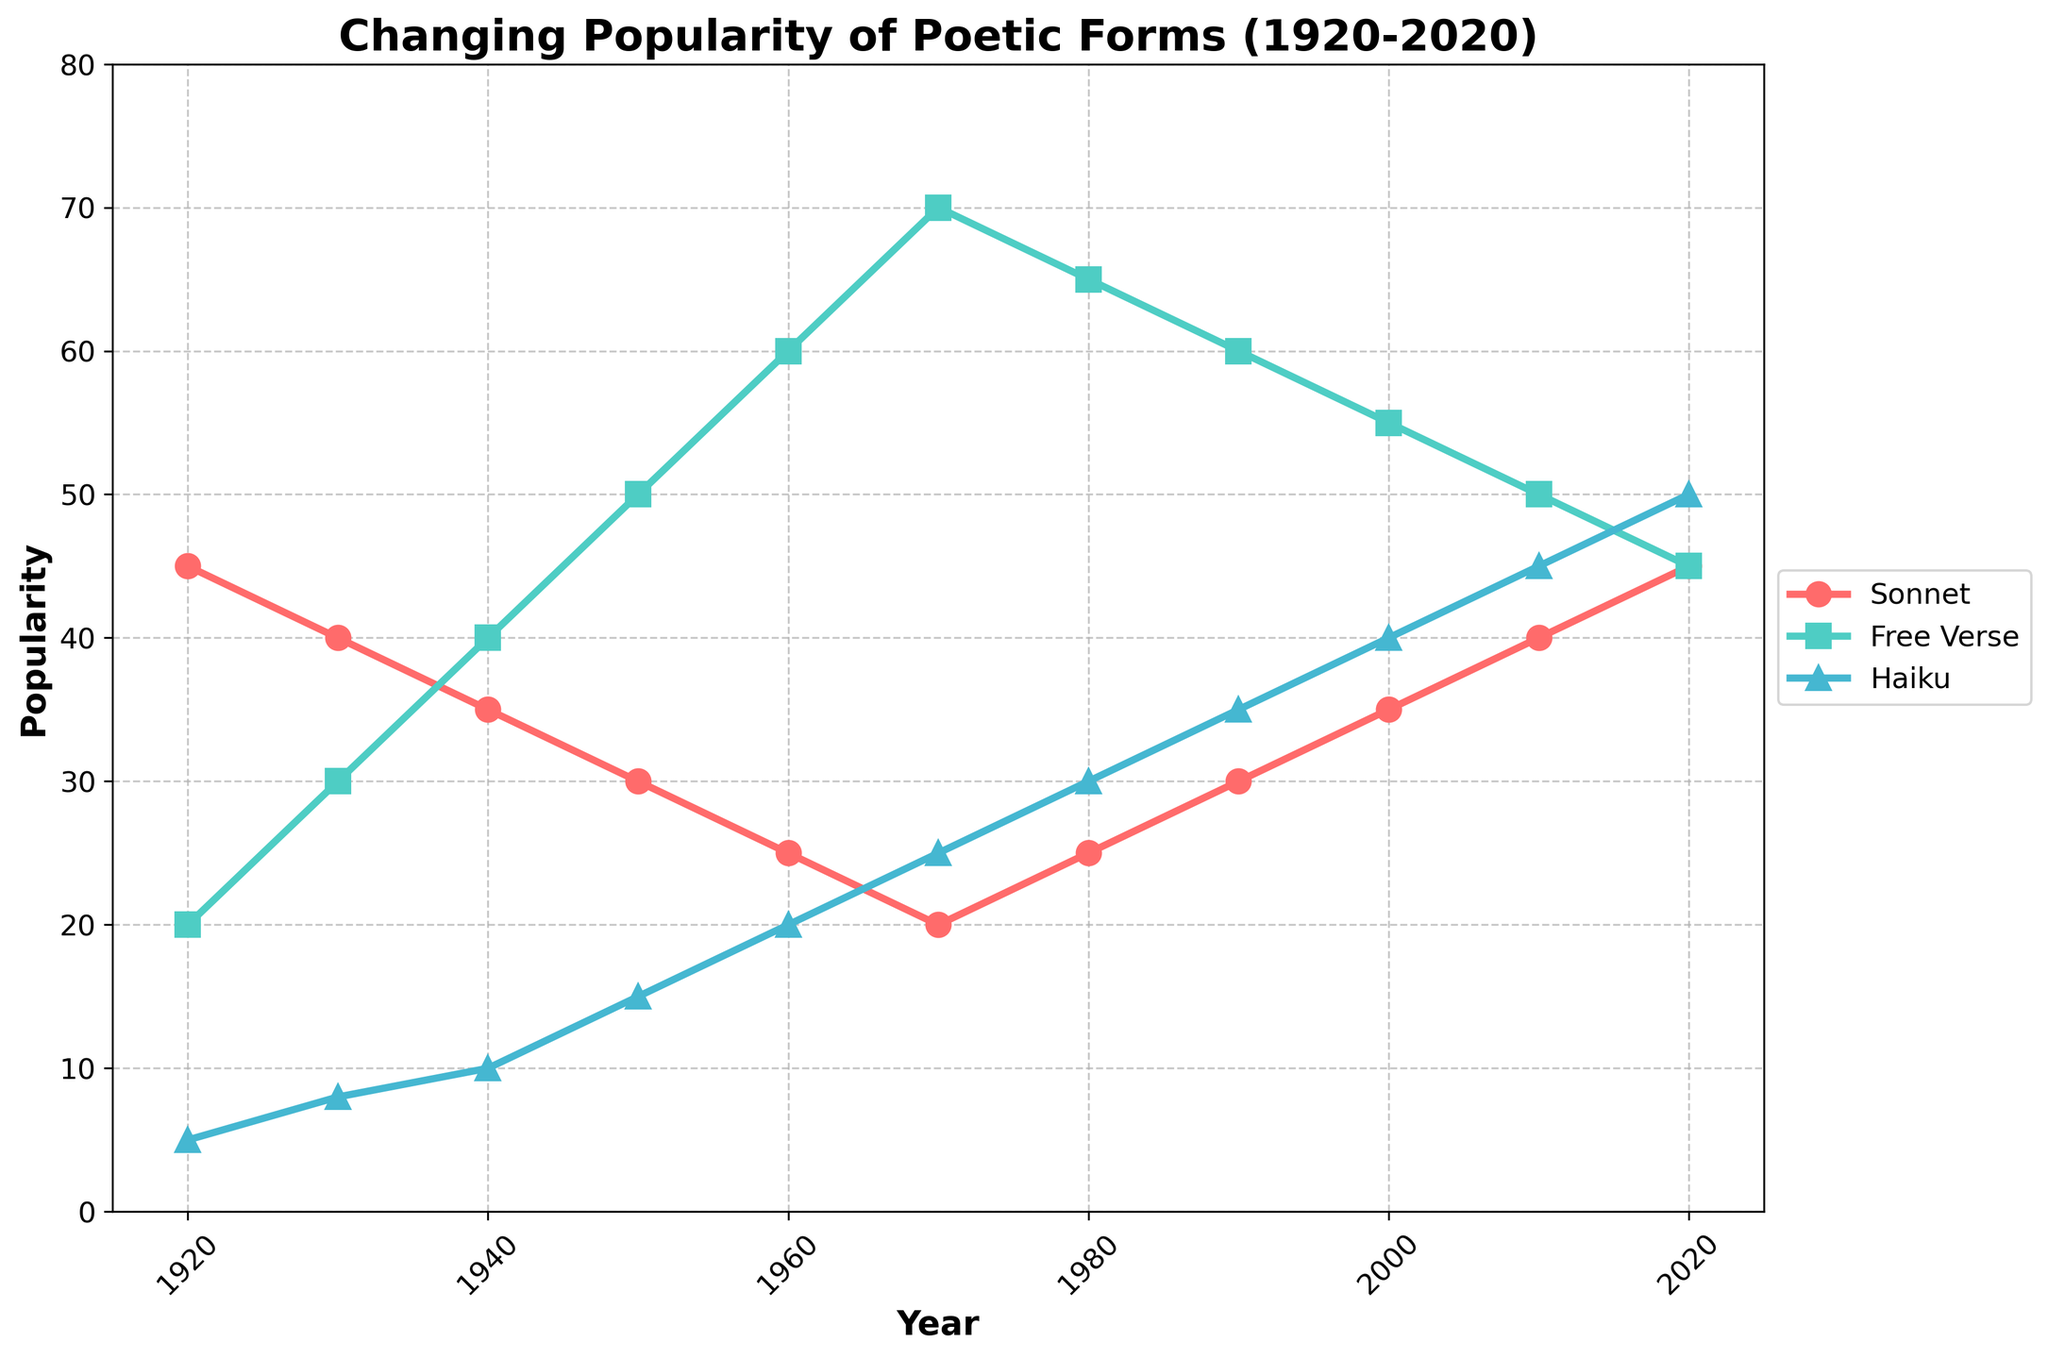What was the popularity of Sonnets and Free Verse in 1950, and what is their combined popularity? The popularity of Sonnets in 1950 was 30, and for Free Verse, it was 50. Their combined popularity is 30 + 50 = 80.
Answer: 80 In which year was the popularity of Haiku highest, and what was its value? The highest popularity of Haiku occurred in 2020, with a value of 50.
Answer: 2020 and 50 Which poetic form had the least popularity in the year 1930? In 1930, the popularity values were Sonnets: 40, Free Verse: 30, and Haiku: 8. Haiku was the least popular.
Answer: Haiku By how much did the popularity of Free Verse change from 1920 to 1980? The popularity of Free Verse in 1920 was 20, and in 1980 it was 65. The change is 65 - 20 = 45.
Answer: 45 How many times did the popularity of Sonnets reach 45 in the recorded period? By looking at the chart, the popularity of Sonnets reached 45 in 1920 and 2020, so it happened twice.
Answer: 2 Which poetic form had the steepest increase in popularity from 1950 to 1960? The popularity values of 1950 and 1960 are as follows – Sonnets: 30 to 25 (decrease of 5), Free Verse: 50 to 60 (increase of 10), Haiku: 15 to 20 (increase of 5). Free Verse had the steepest increase.
Answer: Free Verse Over how many decades was the popularity of Haiku below that of Sonnets? By examining each corresponding decade on the graph from 1920 to 2020, Haiku is below Sonnets in five decades: 1920, 1930, 1940, 1950, and 1960.
Answer: 5 What are the values of Free Verse and Haiku at their minimum popularity points, and in which year do these minima occur? The minimum value for Free Verse is 20 in 1920, and for Haiku, it is 5 in 1920.
Answer: 20 and 5 in 1920 Considering just Free Verse and Haiku, is there any year in which their popularity is equal? By analyzing the graph, you can see there is no year where the popularity of Free Verse and Haiku is equal.
Answer: No 